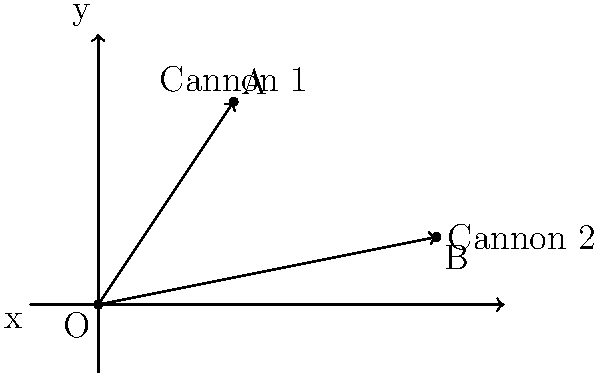During a Civil War reenactment, two cannons are positioned on a battlefield. Cannon 1 is located at point A(2,3) and Cannon 2 is at point B(5,1). Both cannons fire from the origin O(0,0). Calculate the angle between their firing trajectories to the nearest degree. To find the angle between the firing trajectories, we'll use the slopes of the lines OA and OB, then apply the formula for the angle between two lines.

Step 1: Calculate the slopes of OA and OB.
Slope of OA (m₁) = $\frac{y_A - y_O}{x_A - x_O} = \frac{3-0}{2-0} = \frac{3}{2}$
Slope of OB (m₂) = $\frac{y_B - y_O}{x_B - x_O} = \frac{1-0}{5-0} = \frac{1}{5}$

Step 2: Use the formula for the angle between two lines:
$\tan \theta = |\frac{m_1 - m_2}{1 + m_1m_2}|$

Step 3: Substitute the slopes into the formula:
$\tan \theta = |\frac{\frac{3}{2} - \frac{1}{5}}{1 + \frac{3}{2} \cdot \frac{1}{5}}|$

Step 4: Simplify the fraction:
$\tan \theta = |\frac{\frac{15}{10} - \frac{2}{10}}{1 + \frac{3}{10}}| = |\frac{\frac{13}{10}}{\frac{13}{10}}| = 1$

Step 5: Calculate the angle using the inverse tangent function:
$\theta = \arctan(1) \approx 45°$

Therefore, the angle between the firing trajectories is approximately 45°.
Answer: 45° 